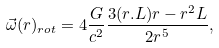<formula> <loc_0><loc_0><loc_500><loc_500>\vec { \omega } ( { r } ) _ { r o t } = 4 \frac { G } { c ^ { 2 } } \frac { 3 ( { r } . { L } ) { r } - r ^ { 2 } { L } } { 2 r ^ { 5 } } ,</formula> 